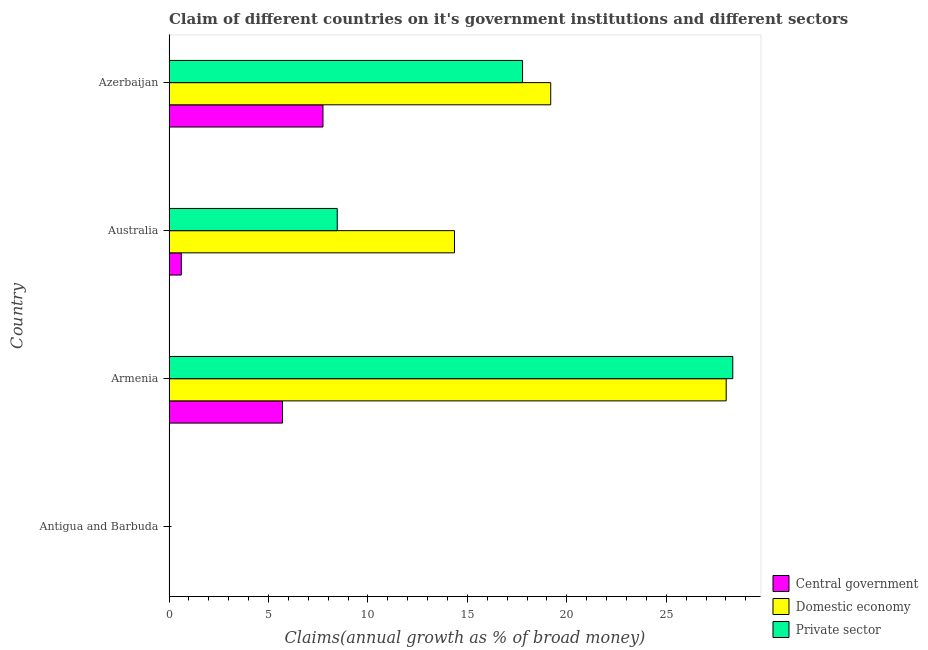How many different coloured bars are there?
Ensure brevity in your answer.  3. Are the number of bars per tick equal to the number of legend labels?
Offer a very short reply. No. Are the number of bars on each tick of the Y-axis equal?
Provide a succinct answer. No. How many bars are there on the 1st tick from the top?
Provide a succinct answer. 3. How many bars are there on the 2nd tick from the bottom?
Provide a succinct answer. 3. What is the label of the 4th group of bars from the top?
Your answer should be very brief. Antigua and Barbuda. In how many cases, is the number of bars for a given country not equal to the number of legend labels?
Ensure brevity in your answer.  1. What is the percentage of claim on the central government in Armenia?
Keep it short and to the point. 5.71. Across all countries, what is the maximum percentage of claim on the domestic economy?
Offer a very short reply. 28.01. In which country was the percentage of claim on the central government maximum?
Your response must be concise. Azerbaijan. What is the total percentage of claim on the private sector in the graph?
Offer a very short reply. 54.58. What is the difference between the percentage of claim on the domestic economy in Armenia and that in Azerbaijan?
Ensure brevity in your answer.  8.82. What is the difference between the percentage of claim on the central government in Australia and the percentage of claim on the domestic economy in Azerbaijan?
Provide a succinct answer. -18.57. What is the average percentage of claim on the private sector per country?
Give a very brief answer. 13.64. What is the difference between the percentage of claim on the private sector and percentage of claim on the domestic economy in Australia?
Ensure brevity in your answer.  -5.89. In how many countries, is the percentage of claim on the central government greater than 18 %?
Offer a terse response. 0. What is the difference between the highest and the second highest percentage of claim on the domestic economy?
Make the answer very short. 8.82. What is the difference between the highest and the lowest percentage of claim on the central government?
Ensure brevity in your answer.  7.74. Does the graph contain any zero values?
Offer a very short reply. Yes. Does the graph contain grids?
Give a very brief answer. No. Where does the legend appear in the graph?
Make the answer very short. Bottom right. How many legend labels are there?
Provide a short and direct response. 3. What is the title of the graph?
Keep it short and to the point. Claim of different countries on it's government institutions and different sectors. Does "Travel services" appear as one of the legend labels in the graph?
Offer a very short reply. No. What is the label or title of the X-axis?
Your answer should be very brief. Claims(annual growth as % of broad money). What is the Claims(annual growth as % of broad money) of Central government in Antigua and Barbuda?
Make the answer very short. 0. What is the Claims(annual growth as % of broad money) of Domestic economy in Antigua and Barbuda?
Provide a succinct answer. 0. What is the Claims(annual growth as % of broad money) of Private sector in Antigua and Barbuda?
Your response must be concise. 0. What is the Claims(annual growth as % of broad money) in Central government in Armenia?
Keep it short and to the point. 5.71. What is the Claims(annual growth as % of broad money) in Domestic economy in Armenia?
Keep it short and to the point. 28.01. What is the Claims(annual growth as % of broad money) of Private sector in Armenia?
Offer a very short reply. 28.35. What is the Claims(annual growth as % of broad money) in Central government in Australia?
Your answer should be compact. 0.62. What is the Claims(annual growth as % of broad money) of Domestic economy in Australia?
Keep it short and to the point. 14.35. What is the Claims(annual growth as % of broad money) of Private sector in Australia?
Offer a terse response. 8.46. What is the Claims(annual growth as % of broad money) of Central government in Azerbaijan?
Provide a succinct answer. 7.74. What is the Claims(annual growth as % of broad money) of Domestic economy in Azerbaijan?
Ensure brevity in your answer.  19.19. What is the Claims(annual growth as % of broad money) of Private sector in Azerbaijan?
Make the answer very short. 17.78. Across all countries, what is the maximum Claims(annual growth as % of broad money) in Central government?
Your answer should be very brief. 7.74. Across all countries, what is the maximum Claims(annual growth as % of broad money) of Domestic economy?
Provide a succinct answer. 28.01. Across all countries, what is the maximum Claims(annual growth as % of broad money) in Private sector?
Your response must be concise. 28.35. Across all countries, what is the minimum Claims(annual growth as % of broad money) in Domestic economy?
Your response must be concise. 0. What is the total Claims(annual growth as % of broad money) in Central government in the graph?
Make the answer very short. 14.07. What is the total Claims(annual growth as % of broad money) in Domestic economy in the graph?
Your answer should be very brief. 61.56. What is the total Claims(annual growth as % of broad money) of Private sector in the graph?
Provide a succinct answer. 54.58. What is the difference between the Claims(annual growth as % of broad money) in Central government in Armenia and that in Australia?
Ensure brevity in your answer.  5.09. What is the difference between the Claims(annual growth as % of broad money) in Domestic economy in Armenia and that in Australia?
Your answer should be very brief. 13.66. What is the difference between the Claims(annual growth as % of broad money) of Private sector in Armenia and that in Australia?
Ensure brevity in your answer.  19.89. What is the difference between the Claims(annual growth as % of broad money) in Central government in Armenia and that in Azerbaijan?
Keep it short and to the point. -2.03. What is the difference between the Claims(annual growth as % of broad money) of Domestic economy in Armenia and that in Azerbaijan?
Your response must be concise. 8.82. What is the difference between the Claims(annual growth as % of broad money) in Private sector in Armenia and that in Azerbaijan?
Give a very brief answer. 10.57. What is the difference between the Claims(annual growth as % of broad money) of Central government in Australia and that in Azerbaijan?
Ensure brevity in your answer.  -7.12. What is the difference between the Claims(annual growth as % of broad money) of Domestic economy in Australia and that in Azerbaijan?
Ensure brevity in your answer.  -4.84. What is the difference between the Claims(annual growth as % of broad money) in Private sector in Australia and that in Azerbaijan?
Offer a terse response. -9.32. What is the difference between the Claims(annual growth as % of broad money) of Central government in Armenia and the Claims(annual growth as % of broad money) of Domestic economy in Australia?
Provide a succinct answer. -8.64. What is the difference between the Claims(annual growth as % of broad money) of Central government in Armenia and the Claims(annual growth as % of broad money) of Private sector in Australia?
Provide a short and direct response. -2.75. What is the difference between the Claims(annual growth as % of broad money) in Domestic economy in Armenia and the Claims(annual growth as % of broad money) in Private sector in Australia?
Your response must be concise. 19.55. What is the difference between the Claims(annual growth as % of broad money) of Central government in Armenia and the Claims(annual growth as % of broad money) of Domestic economy in Azerbaijan?
Offer a very short reply. -13.48. What is the difference between the Claims(annual growth as % of broad money) of Central government in Armenia and the Claims(annual growth as % of broad money) of Private sector in Azerbaijan?
Your response must be concise. -12.07. What is the difference between the Claims(annual growth as % of broad money) in Domestic economy in Armenia and the Claims(annual growth as % of broad money) in Private sector in Azerbaijan?
Your answer should be compact. 10.24. What is the difference between the Claims(annual growth as % of broad money) of Central government in Australia and the Claims(annual growth as % of broad money) of Domestic economy in Azerbaijan?
Provide a succinct answer. -18.57. What is the difference between the Claims(annual growth as % of broad money) of Central government in Australia and the Claims(annual growth as % of broad money) of Private sector in Azerbaijan?
Ensure brevity in your answer.  -17.16. What is the difference between the Claims(annual growth as % of broad money) of Domestic economy in Australia and the Claims(annual growth as % of broad money) of Private sector in Azerbaijan?
Your answer should be very brief. -3.42. What is the average Claims(annual growth as % of broad money) in Central government per country?
Make the answer very short. 3.52. What is the average Claims(annual growth as % of broad money) in Domestic economy per country?
Your response must be concise. 15.39. What is the average Claims(annual growth as % of broad money) of Private sector per country?
Ensure brevity in your answer.  13.65. What is the difference between the Claims(annual growth as % of broad money) of Central government and Claims(annual growth as % of broad money) of Domestic economy in Armenia?
Your answer should be very brief. -22.31. What is the difference between the Claims(annual growth as % of broad money) of Central government and Claims(annual growth as % of broad money) of Private sector in Armenia?
Make the answer very short. -22.64. What is the difference between the Claims(annual growth as % of broad money) of Domestic economy and Claims(annual growth as % of broad money) of Private sector in Armenia?
Make the answer very short. -0.33. What is the difference between the Claims(annual growth as % of broad money) in Central government and Claims(annual growth as % of broad money) in Domestic economy in Australia?
Make the answer very short. -13.73. What is the difference between the Claims(annual growth as % of broad money) in Central government and Claims(annual growth as % of broad money) in Private sector in Australia?
Offer a terse response. -7.84. What is the difference between the Claims(annual growth as % of broad money) of Domestic economy and Claims(annual growth as % of broad money) of Private sector in Australia?
Keep it short and to the point. 5.89. What is the difference between the Claims(annual growth as % of broad money) of Central government and Claims(annual growth as % of broad money) of Domestic economy in Azerbaijan?
Offer a terse response. -11.45. What is the difference between the Claims(annual growth as % of broad money) of Central government and Claims(annual growth as % of broad money) of Private sector in Azerbaijan?
Give a very brief answer. -10.03. What is the difference between the Claims(annual growth as % of broad money) of Domestic economy and Claims(annual growth as % of broad money) of Private sector in Azerbaijan?
Your answer should be compact. 1.42. What is the ratio of the Claims(annual growth as % of broad money) in Central government in Armenia to that in Australia?
Your answer should be compact. 9.22. What is the ratio of the Claims(annual growth as % of broad money) of Domestic economy in Armenia to that in Australia?
Make the answer very short. 1.95. What is the ratio of the Claims(annual growth as % of broad money) of Private sector in Armenia to that in Australia?
Provide a succinct answer. 3.35. What is the ratio of the Claims(annual growth as % of broad money) of Central government in Armenia to that in Azerbaijan?
Provide a short and direct response. 0.74. What is the ratio of the Claims(annual growth as % of broad money) of Domestic economy in Armenia to that in Azerbaijan?
Offer a terse response. 1.46. What is the ratio of the Claims(annual growth as % of broad money) in Private sector in Armenia to that in Azerbaijan?
Your response must be concise. 1.59. What is the ratio of the Claims(annual growth as % of broad money) of Central government in Australia to that in Azerbaijan?
Provide a succinct answer. 0.08. What is the ratio of the Claims(annual growth as % of broad money) of Domestic economy in Australia to that in Azerbaijan?
Your answer should be compact. 0.75. What is the ratio of the Claims(annual growth as % of broad money) in Private sector in Australia to that in Azerbaijan?
Offer a terse response. 0.48. What is the difference between the highest and the second highest Claims(annual growth as % of broad money) in Central government?
Provide a succinct answer. 2.03. What is the difference between the highest and the second highest Claims(annual growth as % of broad money) in Domestic economy?
Offer a very short reply. 8.82. What is the difference between the highest and the second highest Claims(annual growth as % of broad money) of Private sector?
Provide a succinct answer. 10.57. What is the difference between the highest and the lowest Claims(annual growth as % of broad money) in Central government?
Offer a terse response. 7.74. What is the difference between the highest and the lowest Claims(annual growth as % of broad money) in Domestic economy?
Keep it short and to the point. 28.01. What is the difference between the highest and the lowest Claims(annual growth as % of broad money) of Private sector?
Offer a very short reply. 28.35. 